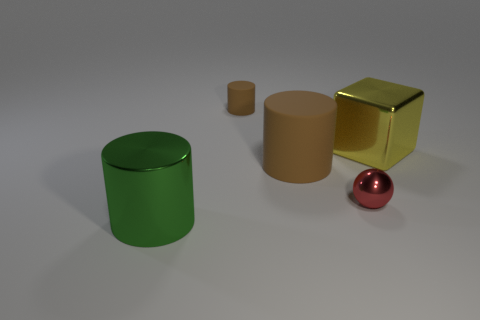Add 2 yellow cubes. How many objects exist? 7 Subtract all small cylinders. How many cylinders are left? 2 Subtract all tiny brown rubber blocks. Subtract all small brown things. How many objects are left? 4 Add 5 red things. How many red things are left? 6 Add 4 brown matte cylinders. How many brown matte cylinders exist? 6 Subtract all brown cylinders. How many cylinders are left? 1 Subtract 1 yellow cubes. How many objects are left? 4 Subtract all spheres. How many objects are left? 4 Subtract all blue cylinders. Subtract all purple cubes. How many cylinders are left? 3 Subtract all blue spheres. How many green cylinders are left? 1 